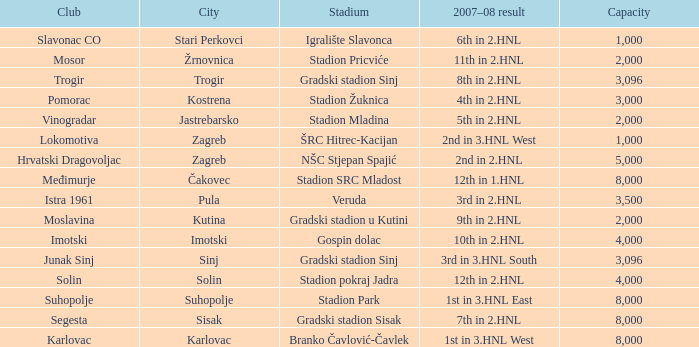What club has 3rd in 3.hnl south as the 2007-08 result? Junak Sinj. 